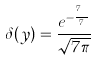Convert formula to latex. <formula><loc_0><loc_0><loc_500><loc_500>\delta ( y ) = \frac { e ^ { - \frac { y ^ { 7 } } { 7 } } } { \sqrt { 7 \pi } }</formula> 